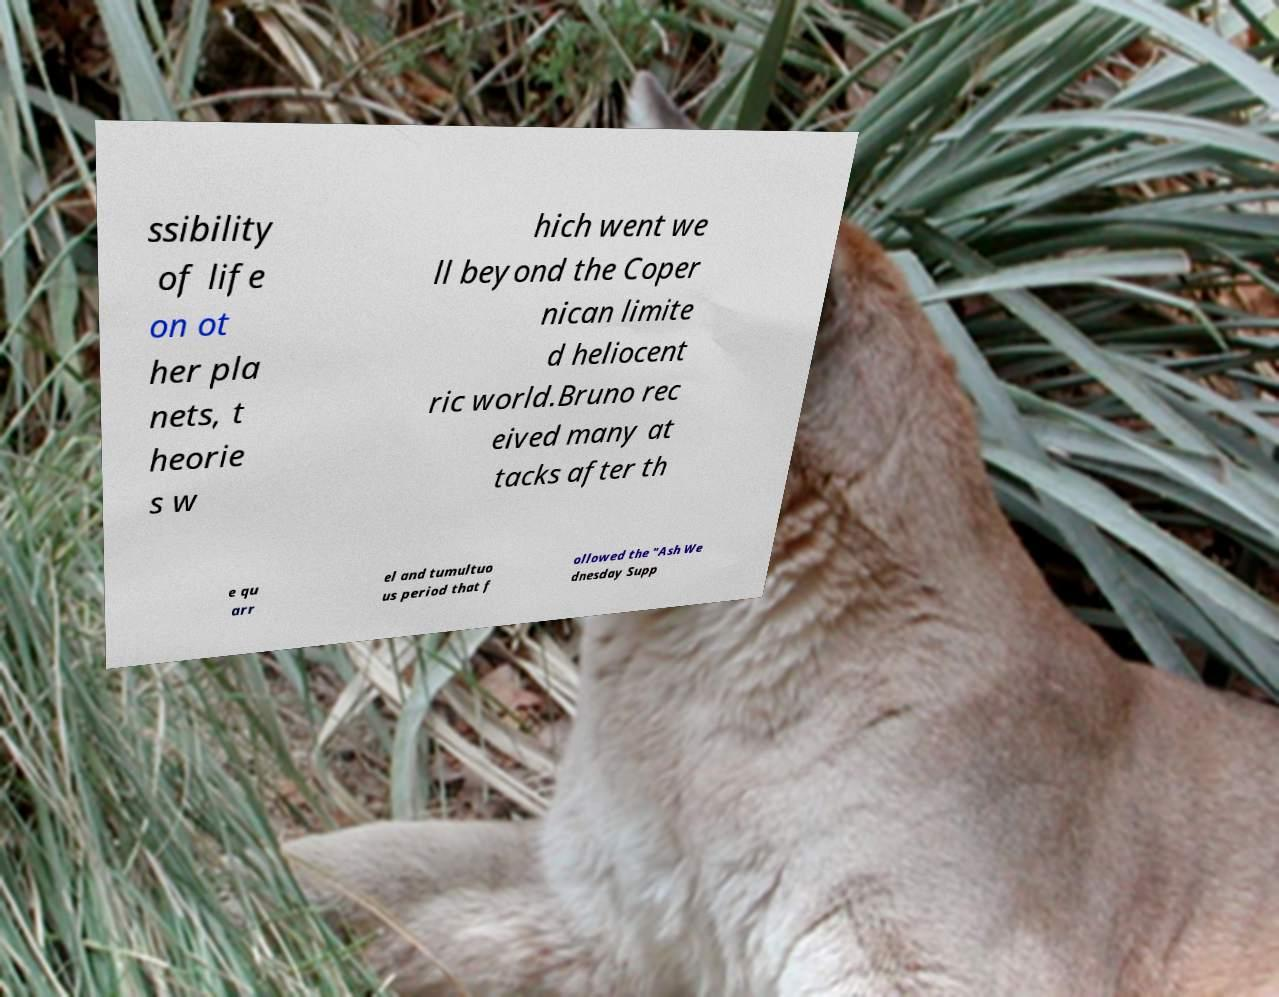Could you assist in decoding the text presented in this image and type it out clearly? ssibility of life on ot her pla nets, t heorie s w hich went we ll beyond the Coper nican limite d heliocent ric world.Bruno rec eived many at tacks after th e qu arr el and tumultuo us period that f ollowed the "Ash We dnesday Supp 